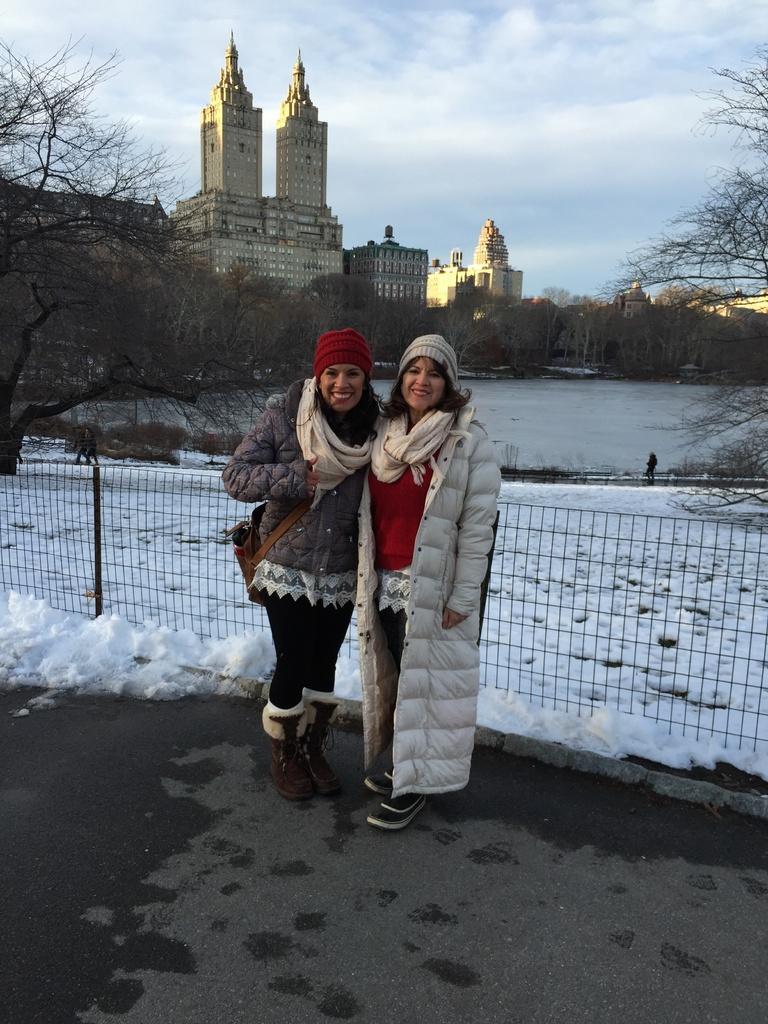In one or two sentences, can you explain what this image depicts? In this image we can see two women wearing the caps and standing on the road and smiling. We can also see the fence and behind the fence we can see the snow, trees and also buildings. Sky is also visible with the clouds. 